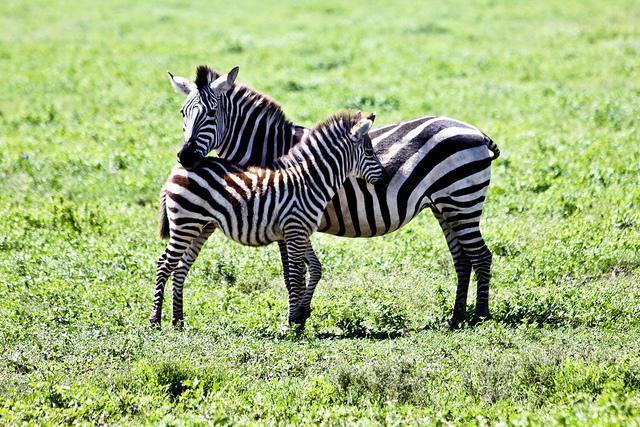How many zebras are in the photo?
Give a very brief answer. 2. How many black cat are this image?
Give a very brief answer. 0. 